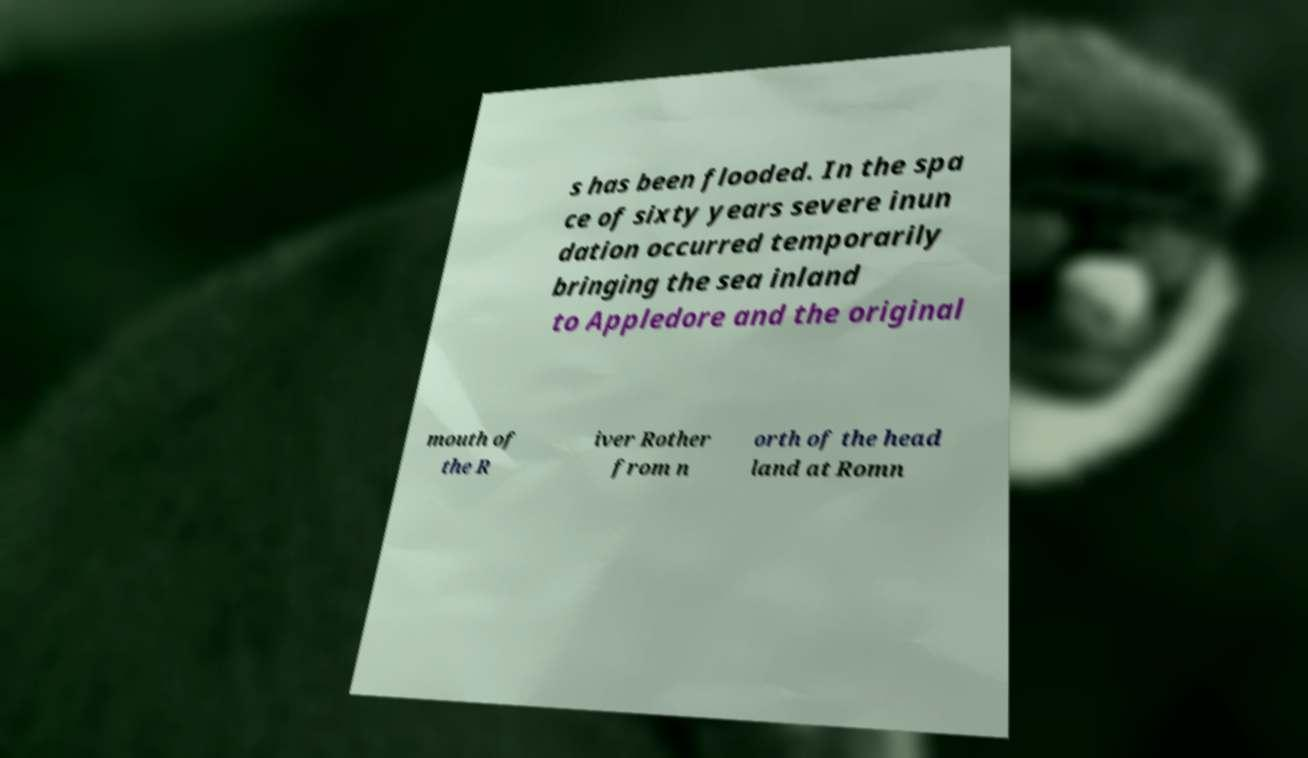For documentation purposes, I need the text within this image transcribed. Could you provide that? s has been flooded. In the spa ce of sixty years severe inun dation occurred temporarily bringing the sea inland to Appledore and the original mouth of the R iver Rother from n orth of the head land at Romn 